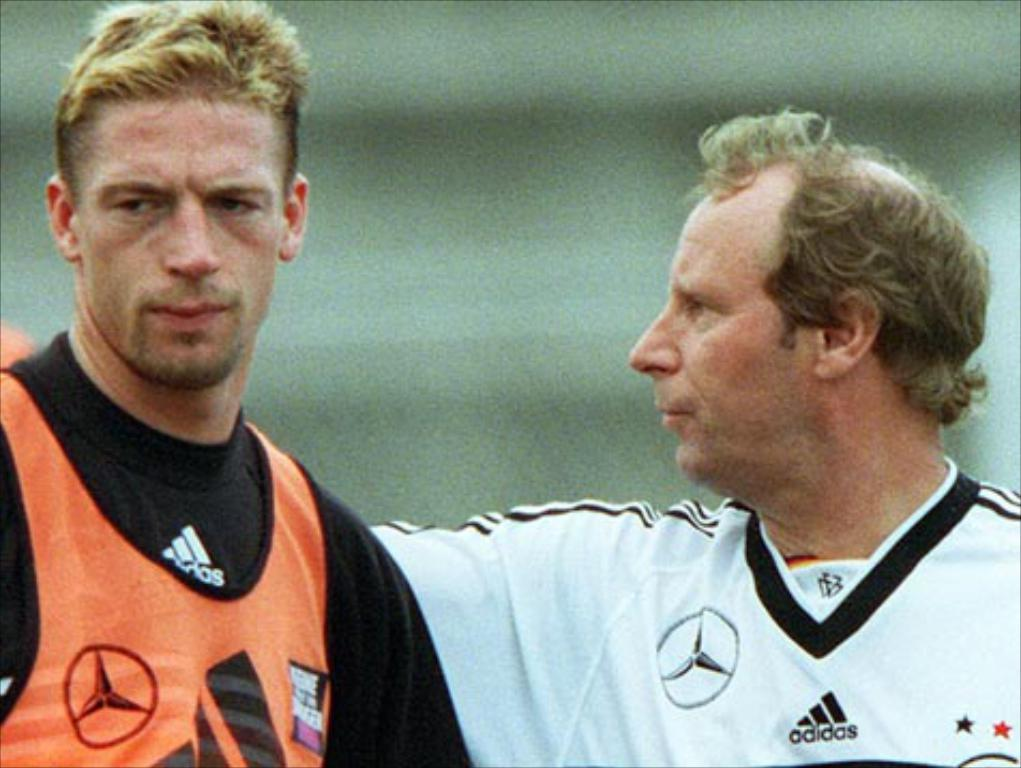<image>
Render a clear and concise summary of the photo. Two men wearing adidas brand shirts stand next to each other and look unhappy. 